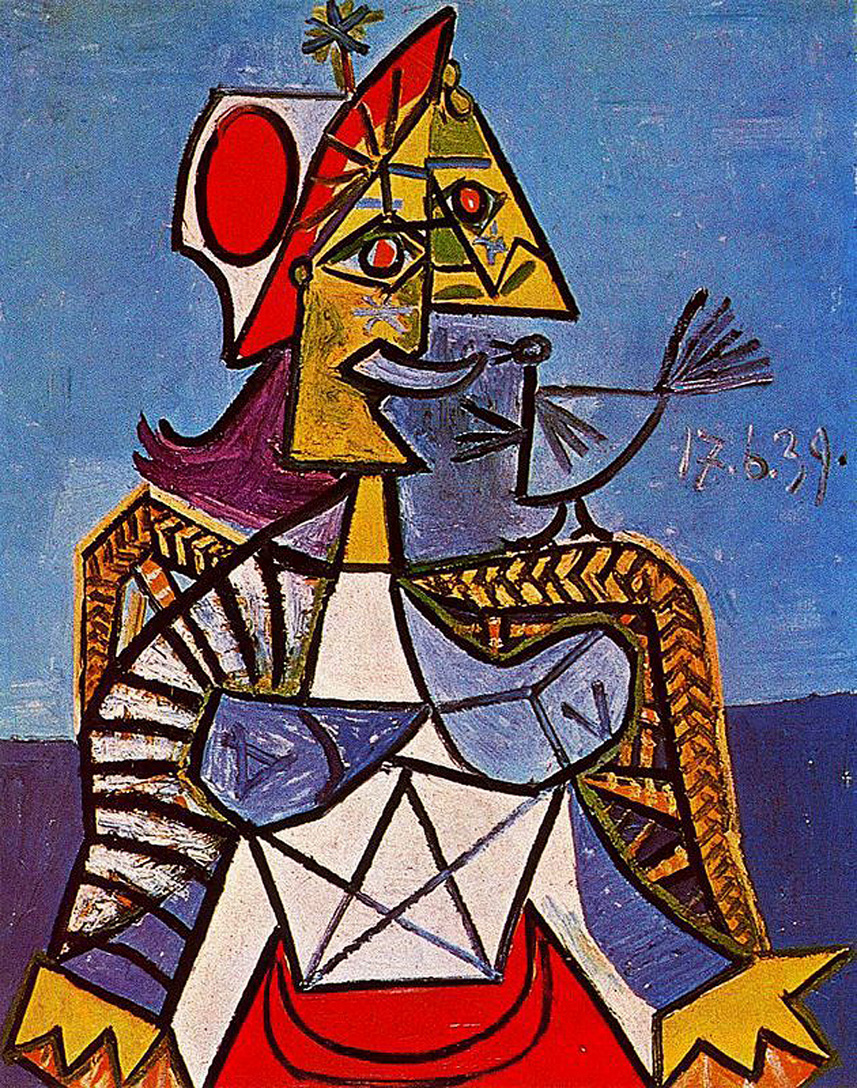Create a dialogue between the crowned figure and the bird, focusing on the themes of power and freedom. Figure: 'Ah, my feathered friend, you hold in your wings the very essence of freedom I yearn for, yet am bound by my crown.'

Bird: 'And you, my sovereign, wield power that I can only dream of from the skies. But tell me, does your crown weigh heavy upon your thoughts?'

Figure: 'Indeed, it does. Every geometric line etched upon me is a path of responsibility and control. The colors of my form, rich and bold, signify the burdens of authority.'

Bird: 'But with authority comes the ability to shape and protect, just as my flight allows me to traverse the boundless sky. We both hold power, though in different realms.'

Figure: 'True, dear bird. Perhaps in our union, we can learn to balance the structured power I command with the liberating freedom of your flight. Together, we create harmony in this geometric world.'

Bird: 'Then let us journey together, blending the regal strength of your crown with the serene liberty of my wings, crafting a narrative where power and freedom coexist in exquisite balance.' 